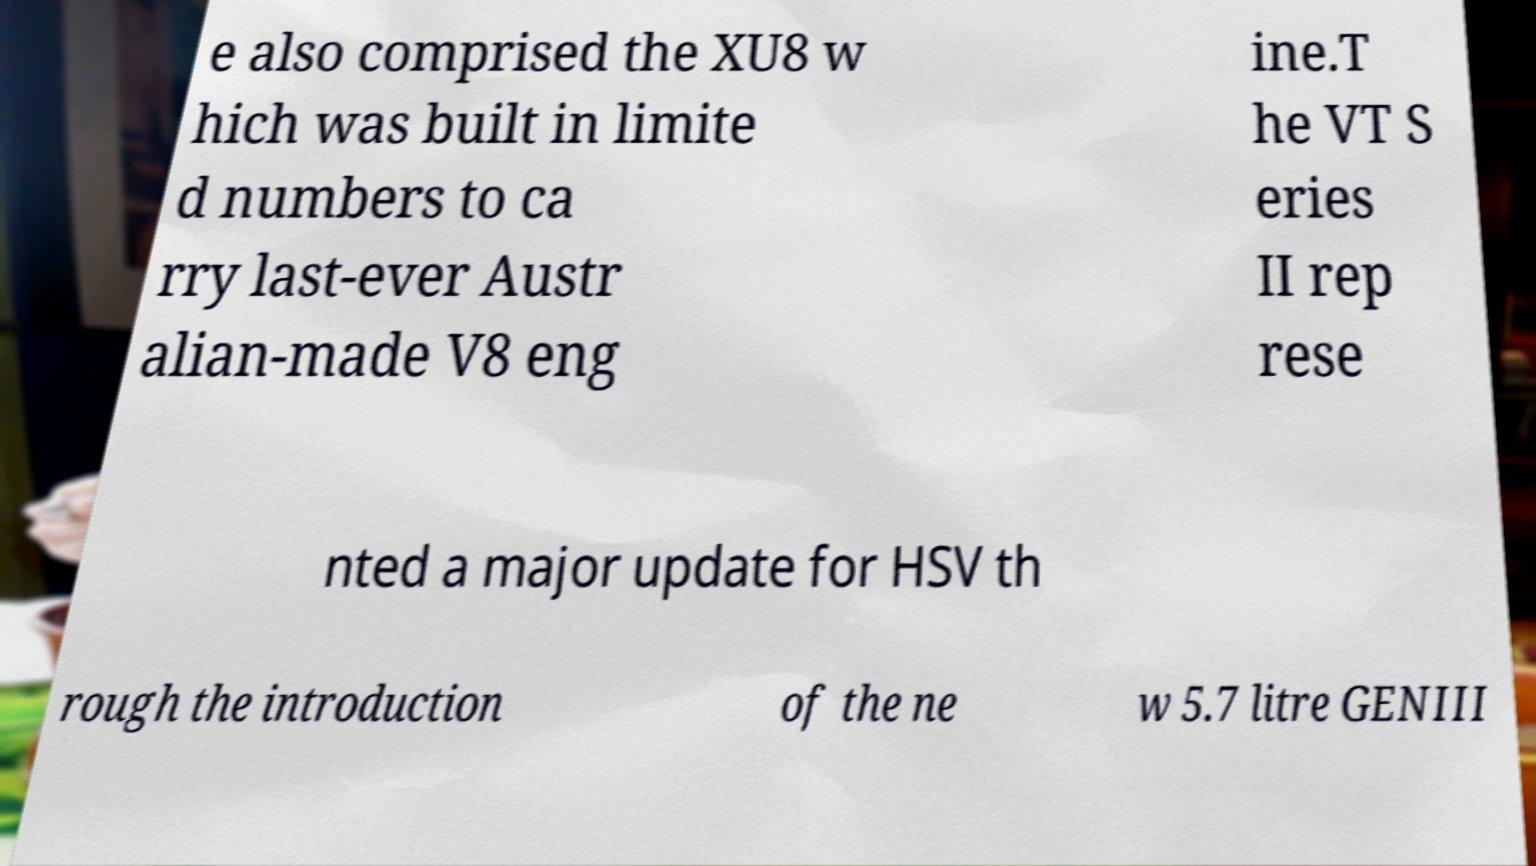Can you accurately transcribe the text from the provided image for me? e also comprised the XU8 w hich was built in limite d numbers to ca rry last-ever Austr alian-made V8 eng ine.T he VT S eries II rep rese nted a major update for HSV th rough the introduction of the ne w 5.7 litre GENIII 